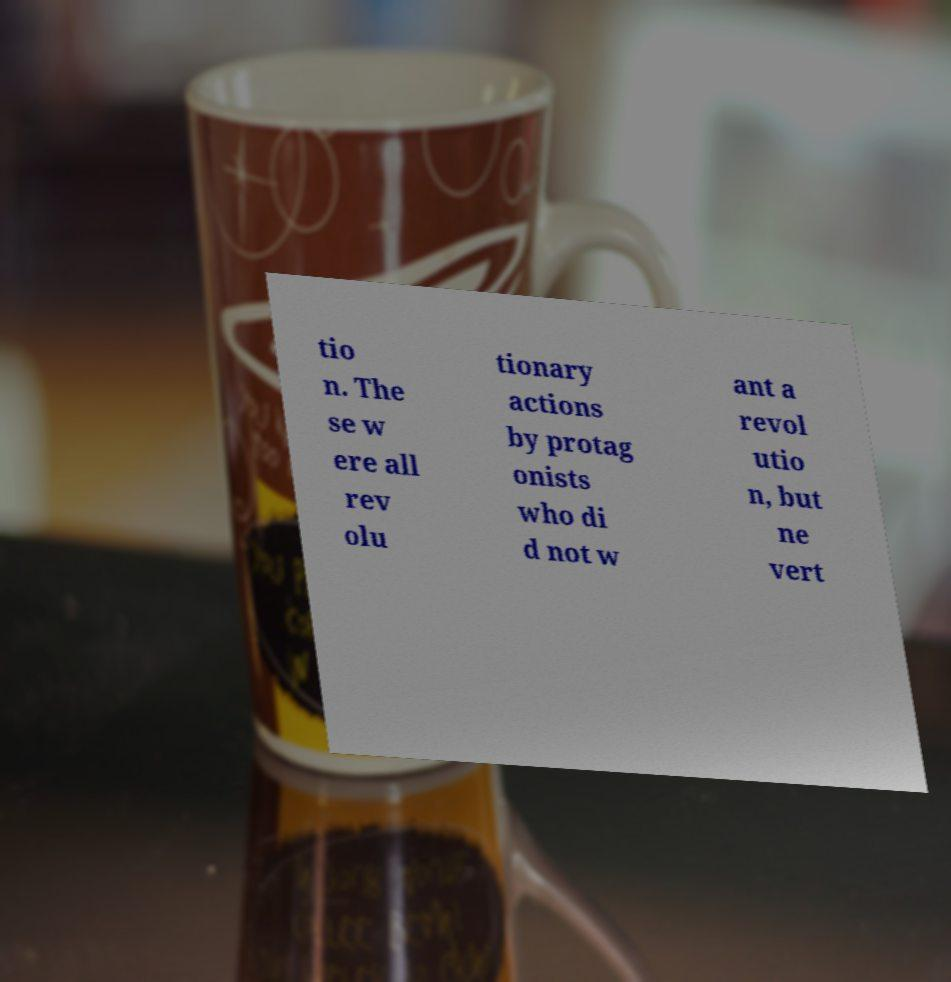What messages or text are displayed in this image? I need them in a readable, typed format. tio n. The se w ere all rev olu tionary actions by protag onists who di d not w ant a revol utio n, but ne vert 